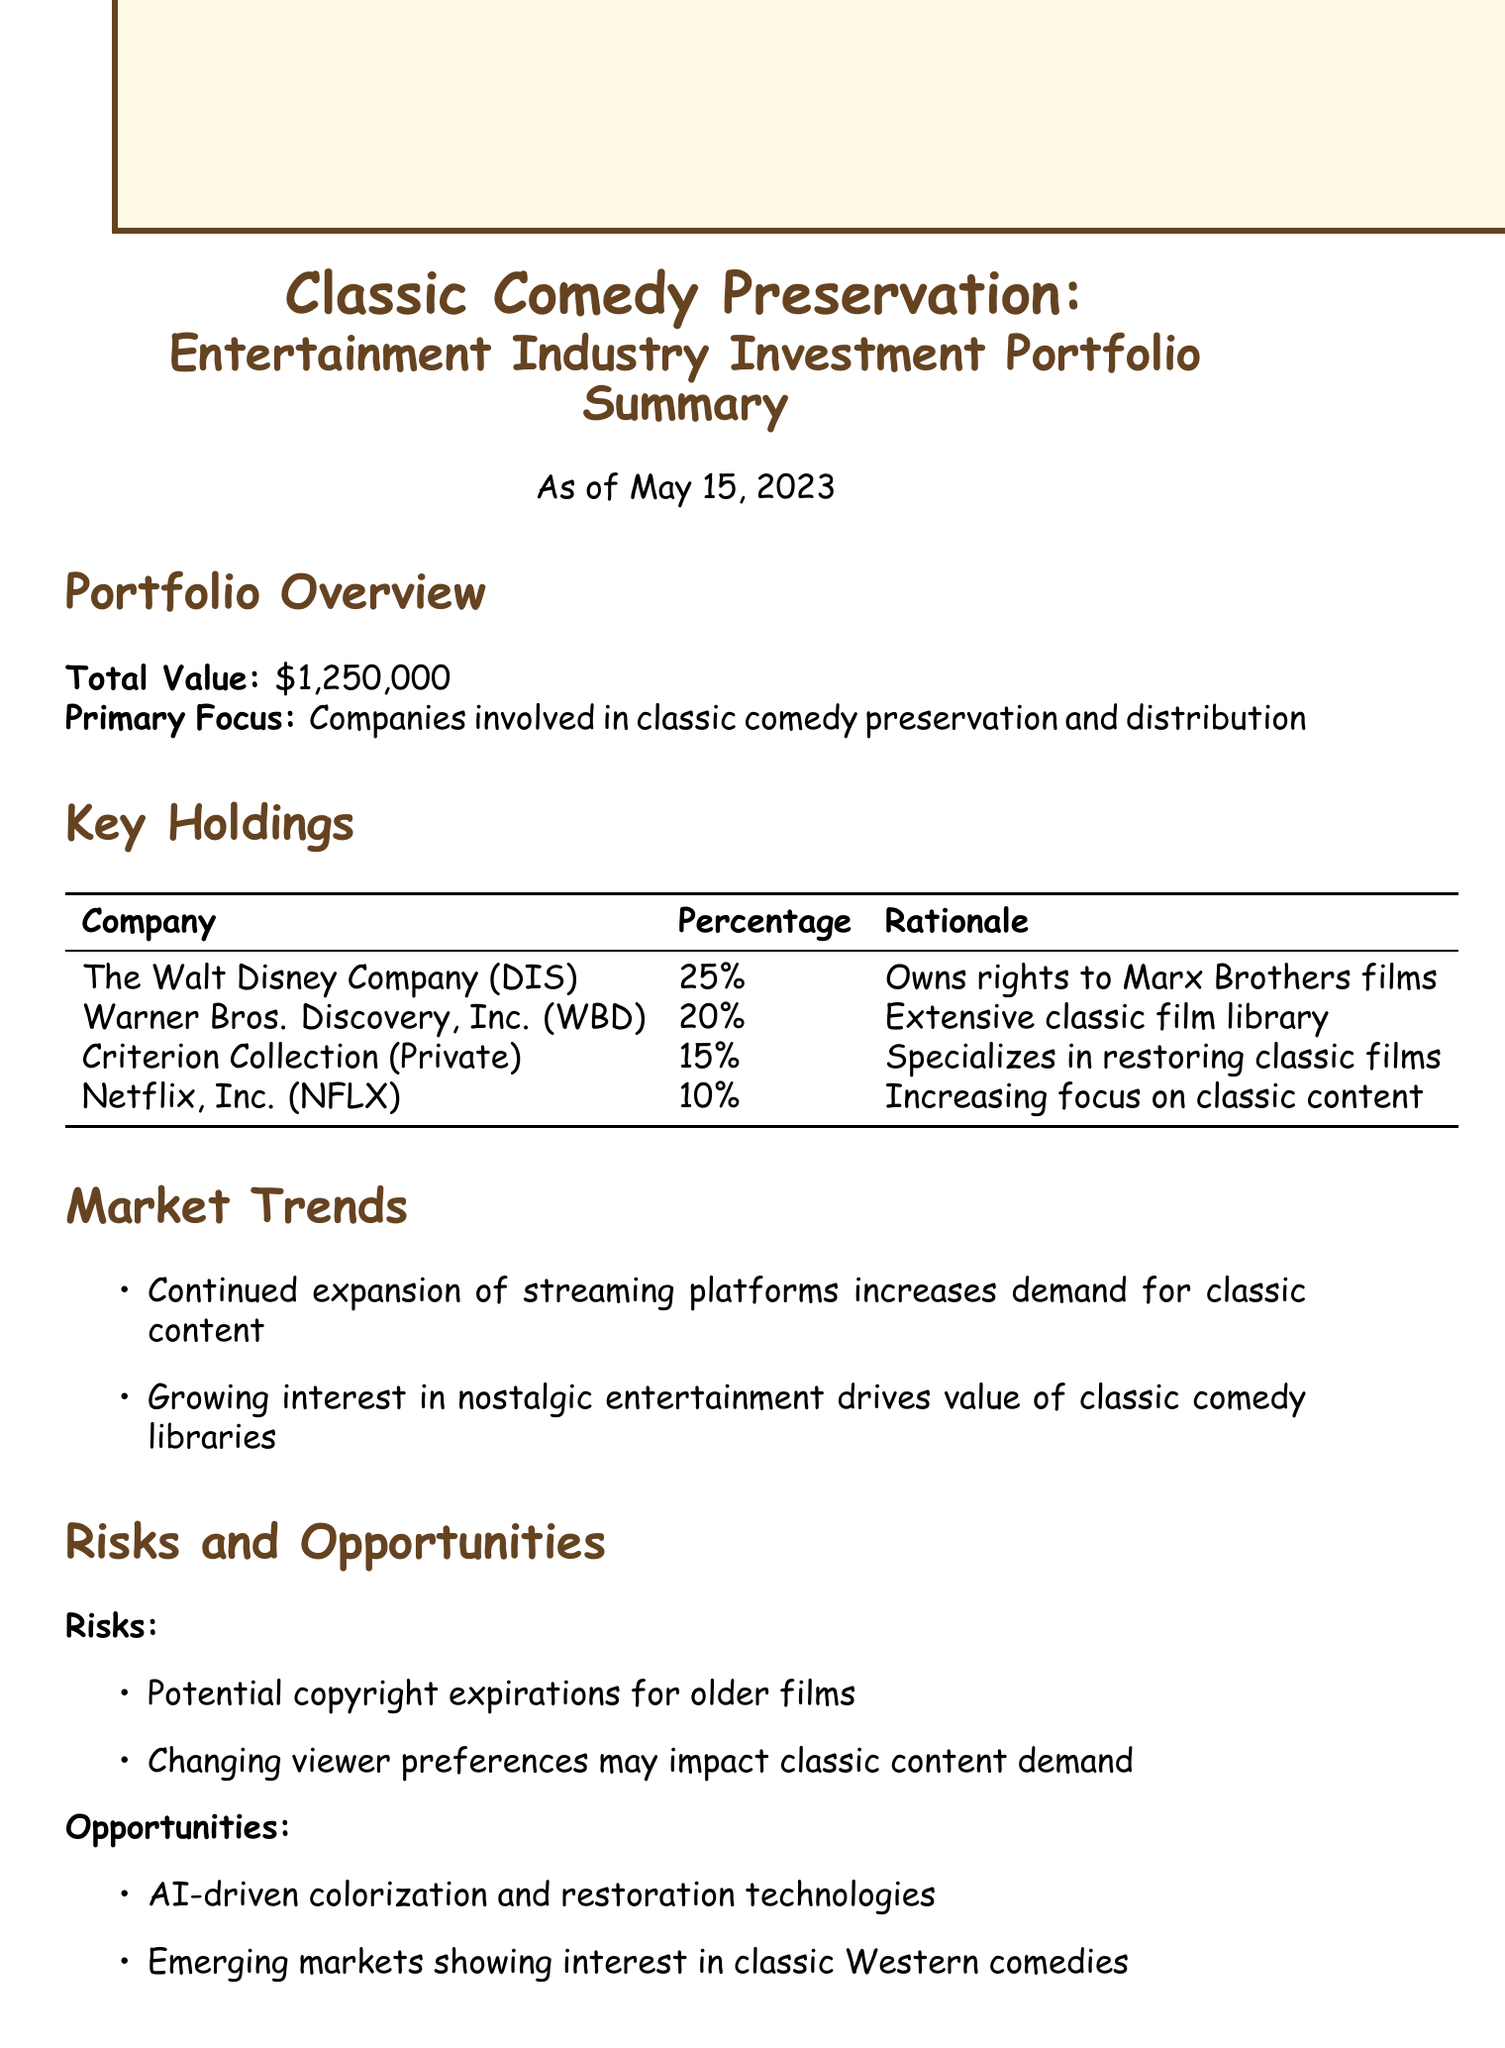what is the report title? The report title is mentioned in the header of the document.
Answer: Classic Comedy Preservation: Entertainment Industry Investment Portfolio Summary what is the total value of the portfolio? The total value is indicated in the Portfolio Overview section of the document.
Answer: $1,250,000 which company holds the highest percentage in the portfolio? The company with the highest percentage is listed in the Key Holdings section.
Answer: The Walt Disney Company (DIS) what is the YTD return of the investment portfolio? The YTD return is provided in the Performance Summary section.
Answer: 8.5% what is one of the risks mentioned in the report? The risks are listed under the Risks and Opportunities section.
Answer: Potential copyright expirations for older films what emerging trend is mentioned in the market trends? The emerging trend is noted in the Market Trends section of the document.
Answer: Continued expansion of streaming platforms increases demand for classic content how much percentage is invested in Criterion Collection? The investment percentage is provided in the Key Holdings section.
Answer: 15% what is the overall outlook for the portfolio? The outlook is summarized in the last section of the document.
Answer: Positive, with expected growth in classic content value as streaming wars intensify 